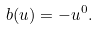Convert formula to latex. <formula><loc_0><loc_0><loc_500><loc_500>b ( u ) = - u ^ { 0 } .</formula> 